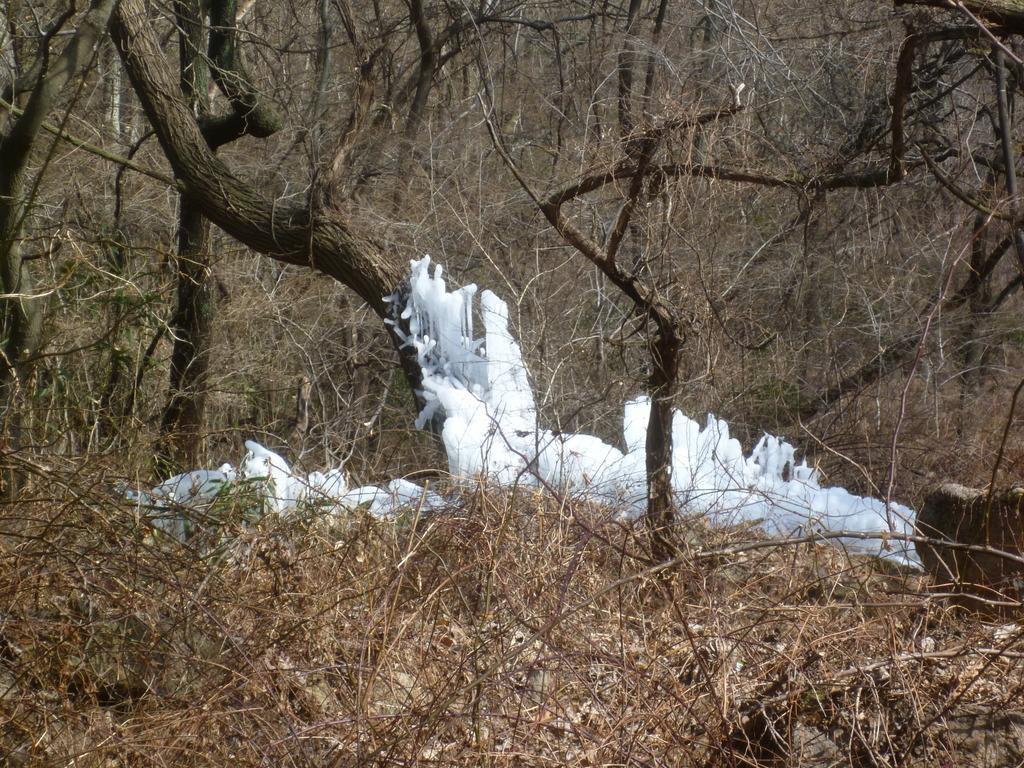Can you describe this image briefly? This image consists of trees and there is something in white color. There is grass in the bottom. These are dried trees. 